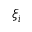Convert formula to latex. <formula><loc_0><loc_0><loc_500><loc_500>\xi _ { i }</formula> 